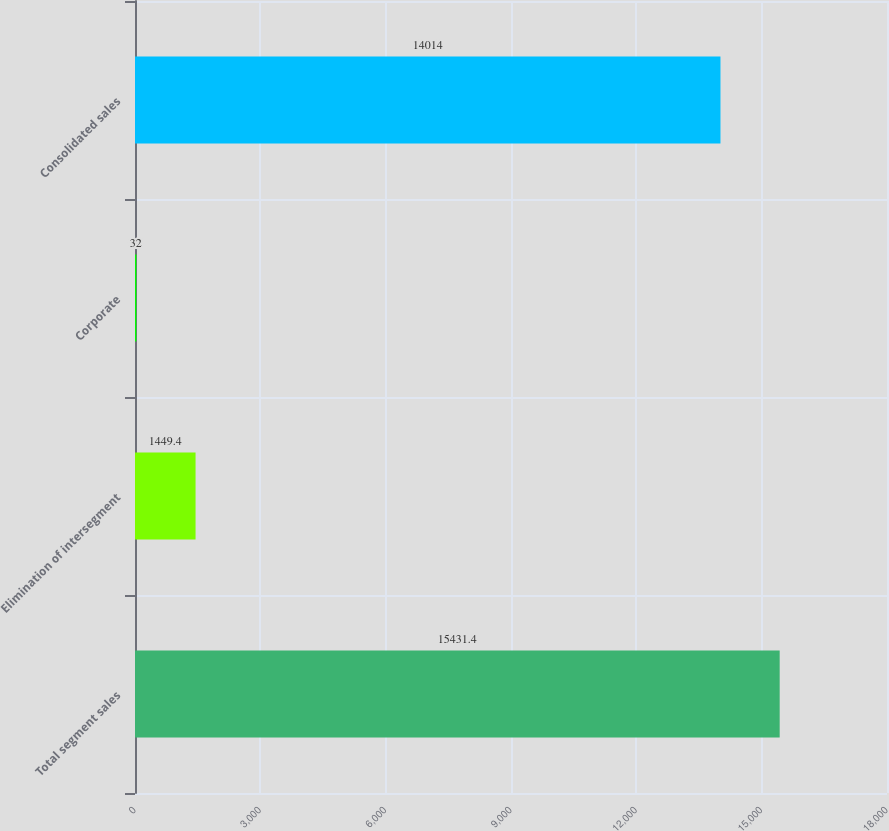<chart> <loc_0><loc_0><loc_500><loc_500><bar_chart><fcel>Total segment sales<fcel>Elimination of intersegment<fcel>Corporate<fcel>Consolidated sales<nl><fcel>15431.4<fcel>1449.4<fcel>32<fcel>14014<nl></chart> 